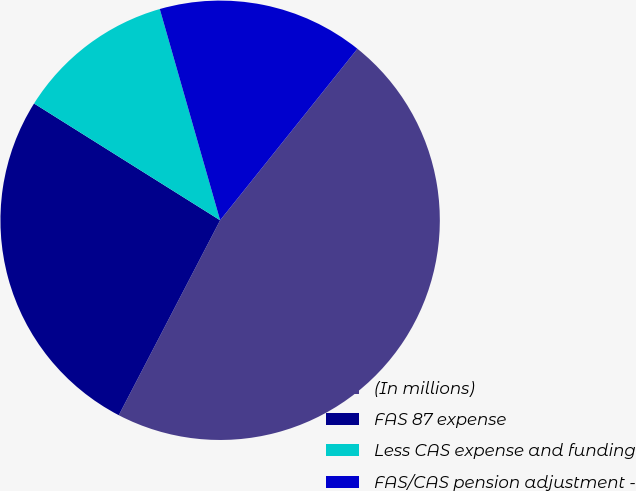Convert chart to OTSL. <chart><loc_0><loc_0><loc_500><loc_500><pie_chart><fcel>(In millions)<fcel>FAS 87 expense<fcel>Less CAS expense and funding<fcel>FAS/CAS pension adjustment -<nl><fcel>46.89%<fcel>26.29%<fcel>11.65%<fcel>15.17%<nl></chart> 